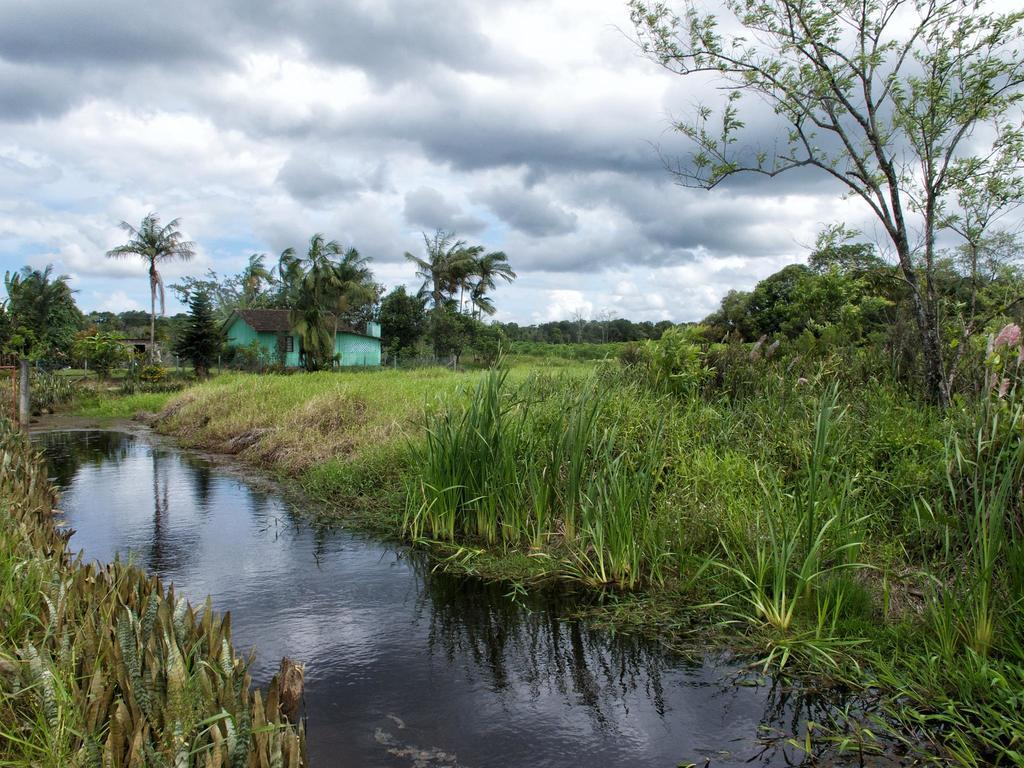What type of structure is present in the image? There is a house in the image. What type of vegetation can be seen in the image? There are trees, plants, and grass visible in the image. What part of the natural environment is visible in the image? Sky and water are visible in the image. What else can be seen in the sky? Clouds are visible in the sky. What type of furniture is visible in the image? There is no furniture visible in the image; it primarily features a house, vegetation, and natural elements. 